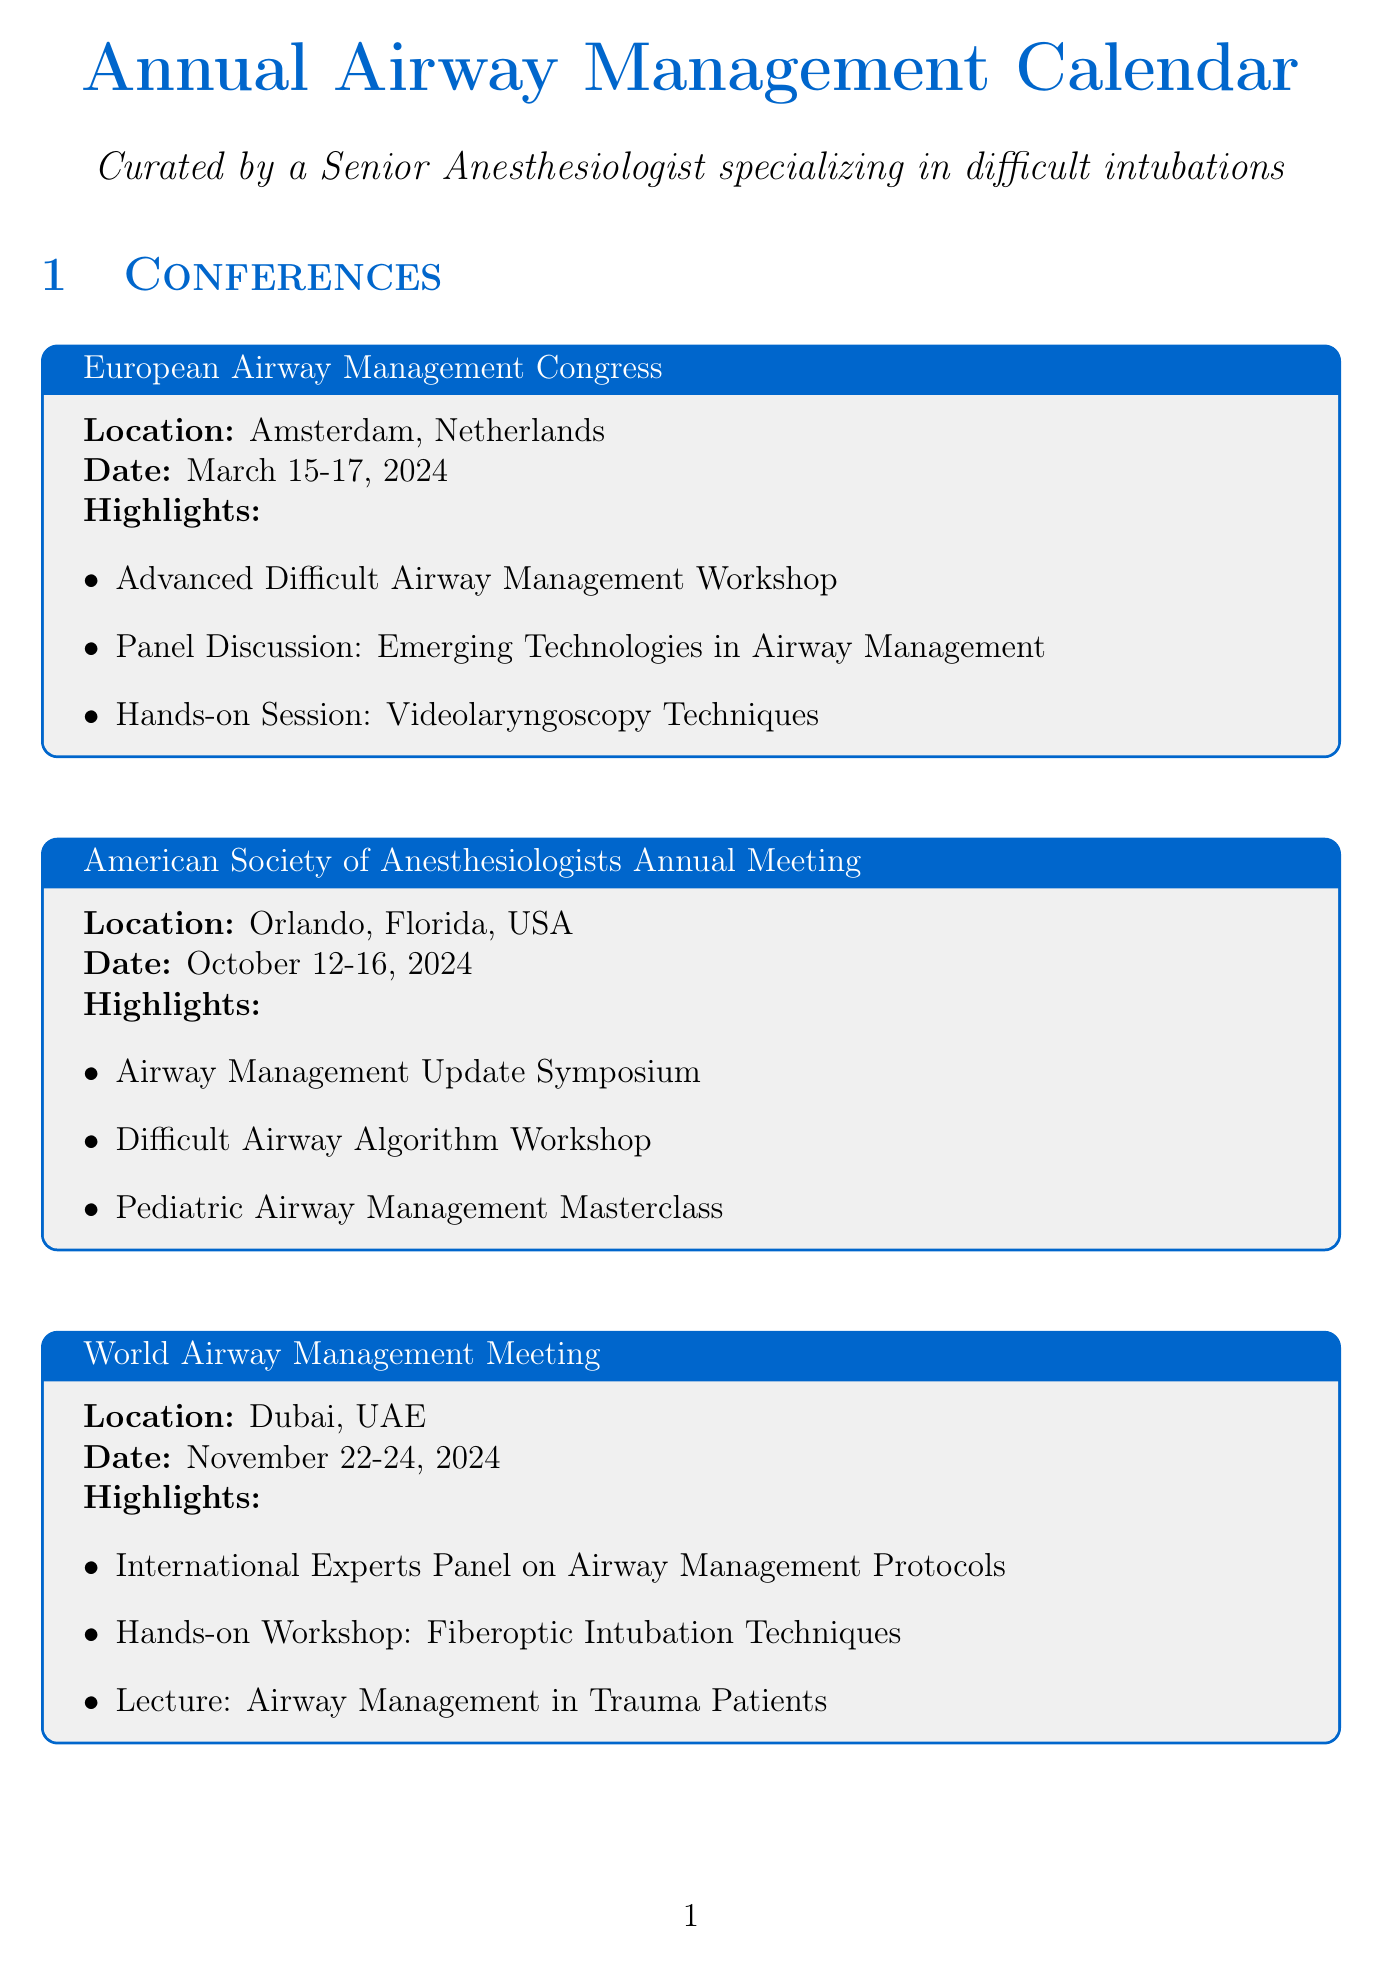What is the date of the European Airway Management Congress? The date is listed directly in the document under the congress details.
Answer: March 15-17, 2024 Where is the American Society of Anesthesiologists Annual Meeting held? The location is specified for the meeting in the document.
Answer: Orlando, Florida, USA What workshop is organized by the Mayo Clinic? The workshop name is presented in the workshops section of the document.
Answer: Advanced Airway Management and Ventilation Strategies Who is the instructor for the Advanced Videolaryngoscopy Techniques session? The instructor's name is mentioned in the hands-on sessions section.
Answer: Dr. Michael F. Aziz How many days does the Pediatric Airway Management Symposium take place? The duration of the symposium is found in the date section of the document.
Answer: 3 days Which event focuses on difficult airway algorithms? The relevant workshop is indicated in the document's workshop highlights.
Answer: Difficult Airway Algorithm Workshop What is one key topic covered in the Ultrasound-Guided Airway Management session? The key topics are listed in the hands-on sessions section of the document.
Answer: Airway ultrasound scanning techniques What type of session focuses on fiberoptic intubation? The document specifies the type of hands-on session in its title.
Answer: Hands-on Workshop Which symposium is scheduled first in 2024? The order is determined by the dates provided in the events section.
Answer: European Airway Management Congress 